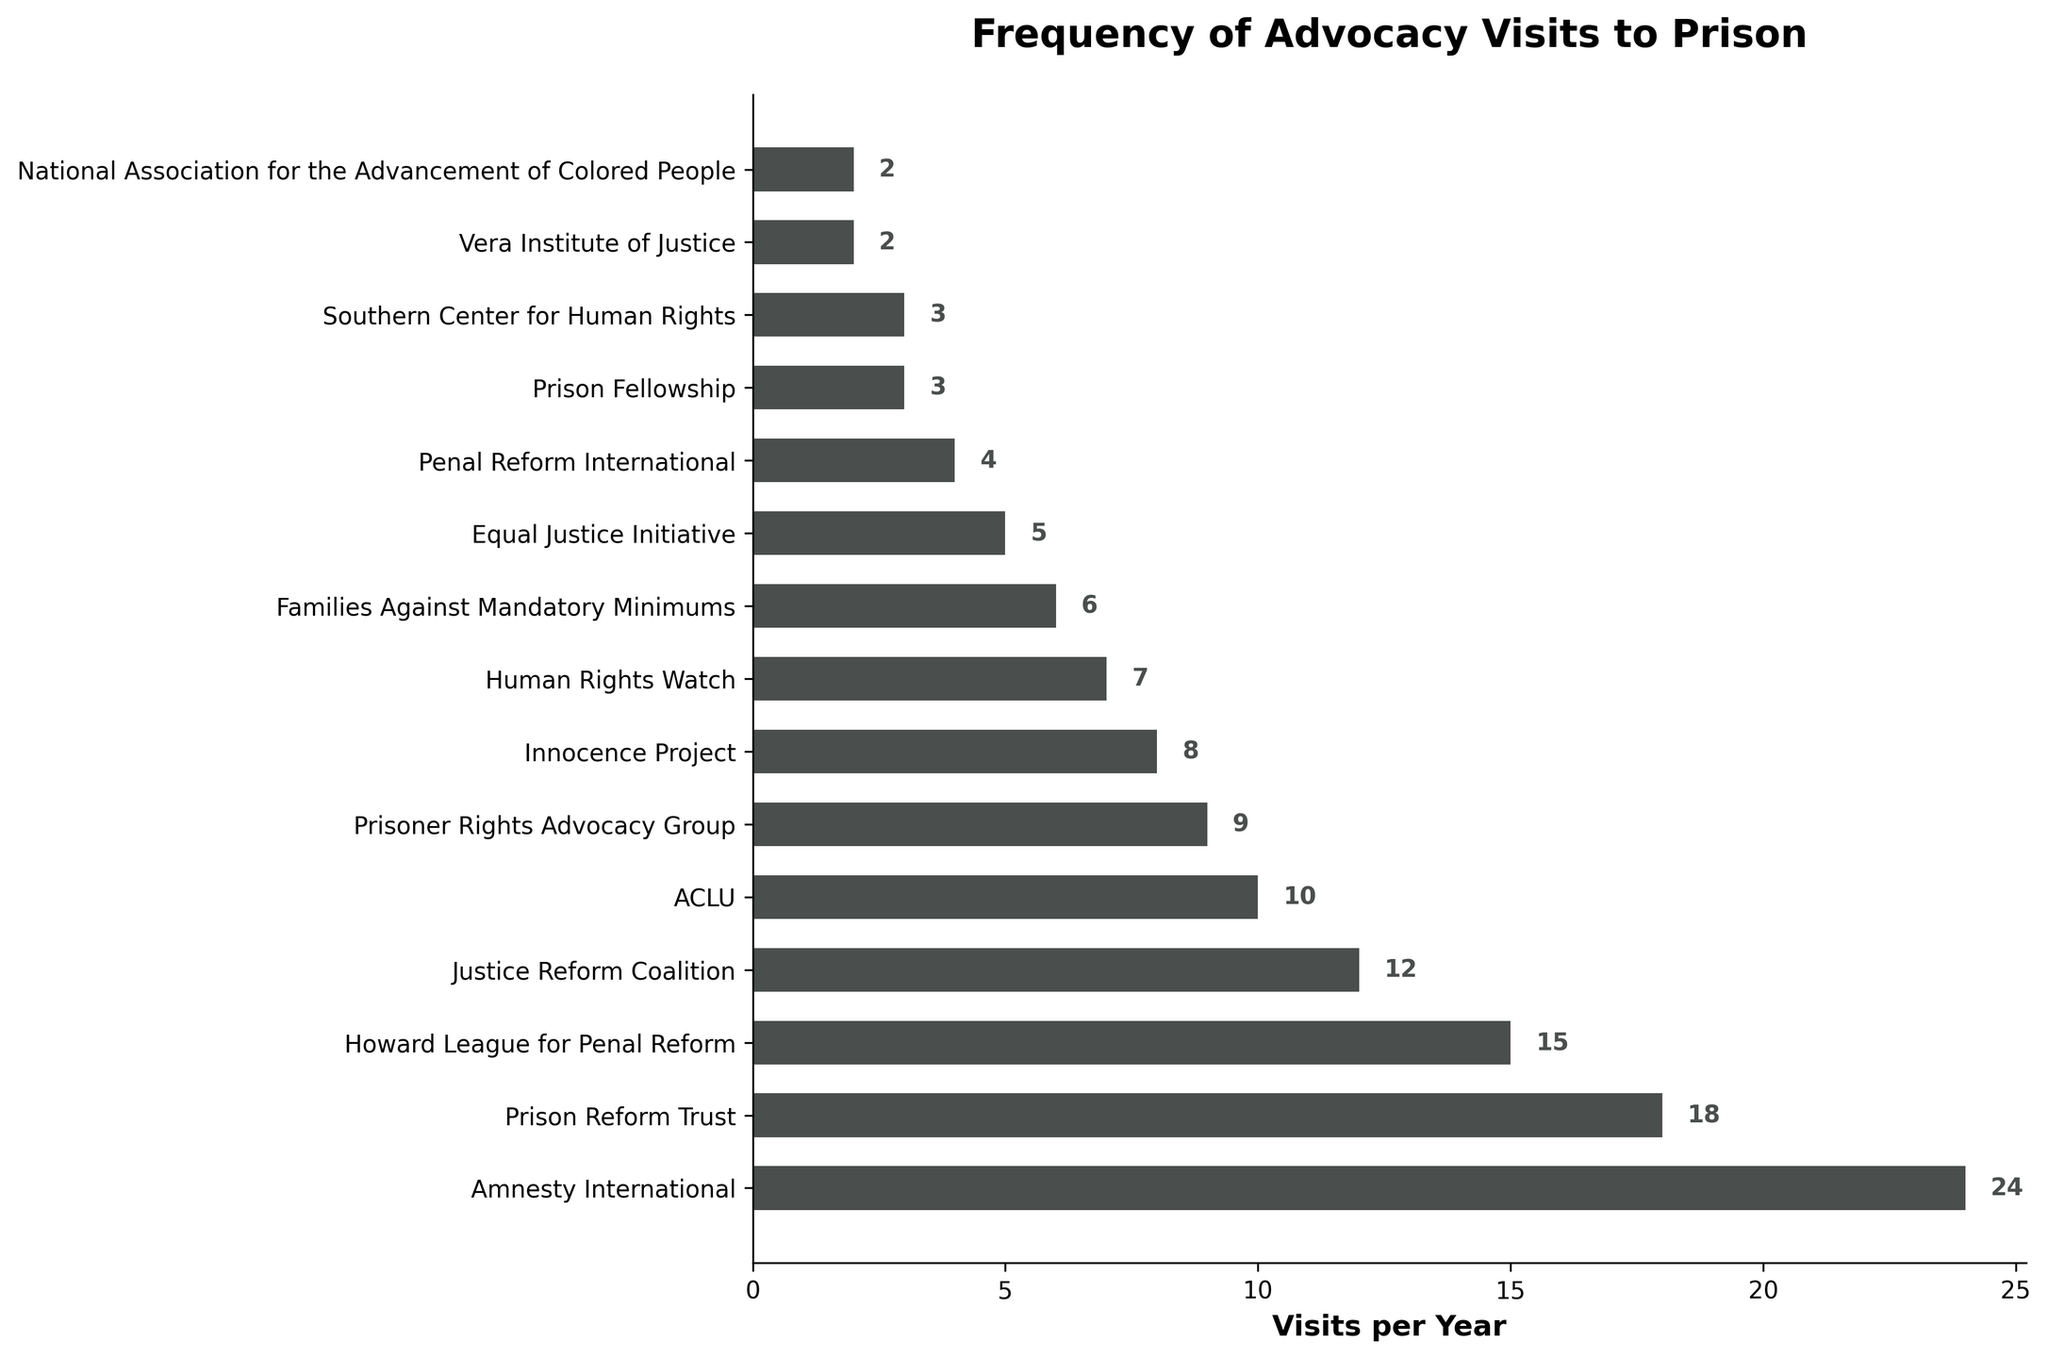Which organization has the highest number of advocacy visits per year? The figure shows the frequency of advocacy visits, and the organization with the longest bar is Amnesty International, making it clear they have the highest number of visits.
Answer: Amnesty International What is the difference in the number of visits per year between Amnesty International and the ACLU? Amnesty International has 24 visits per year, and the ACLU has 10. The difference is 24 - 10 = 14.
Answer: 14 Which organizations have fewer than 10 visits per year? Observing the length of the bars corresponding to visits fewer than 10, the organizations are Prisoner Rights Advocacy Group, Innocence Project, Human Rights Watch, Families Against Mandatory Minimums, Equal Justice Initiative, Penal Reform International, Prison Fellowship, Southern Center for Human Rights, Vera Institute of Justice, and National Association for the Advancement of Colored People.
Answer: Prisoner Rights Advocacy Group, Innocence Project, Human Rights Watch, Families Against Mandatory Minimums, Equal Justice Initiative, Penal Reform International, Prison Fellowship, Southern Center for Human Rights, Vera Institute of Justice, National Association for the Advancement of Colored People How many organizations have more than 10 advocacy visits per year? By counting the bars that extend beyond the 10 visit mark, the organizations include Amnesty International, Prison Reform Trust, Howard League for Penal Reform, and Justice Reform Coalition.
Answer: 4 What is the average number of advocacy visits per year across all organizations? The sum of all visits is 24 + 18 + 15 + 12 + 10 + 9 + 8 + 7 + 6 + 5 + 4 + 3 + 3 + 2 + 2 = 128. There are 15 organizations, so the average is 128 / 15 ≈ 8.53.
Answer: 8.53 Which organization has exactly 5 advocacy visits per year? The bar corresponding to Equal Justice Initiative shows exactly 5 visits per year.
Answer: Equal Justice Initiative Compare the combined number of visits by Amnesty International and Prison Reform Trust to that of the combined visits by Howard League for Penal Reform and ACLU. Which group has more visits? Amnesty International and Prison Reform Trust have a combined total of 24 + 18 = 42 visits, whereas Howard League for Penal Reform and ACLU have 15 + 10 = 25 visits. 42 is greater than 25.
Answer: Amnesty International and Prison Reform Trust What is the median number of visits per year? Listing the visits in ascending order: 2, 2, 3, 3, 4, 5, 6, 7, 8, 9, 10, 12, 15, 18, 24. The median is the middle value of this ordered list, which is 7.
Answer: 7 What is the combined number of visits for the bottom five organizations in terms of visits per year? The bottom five organizations are Vera Institute of Justice (2), National Association for the Advancement of Colored People (2), Prison Fellowship (3), Southern Center for Human Rights (3), and Penal Reform International (4). Their combined visits are 2 + 2 + 3 + 3 + 4 = 14.
Answer: 14 Which organization has the second highest number of advocacy visits per year? The second longest bar after Amnesty International belongs to Prison Reform Trust, indicating they have the second highest number of visits.
Answer: Prison Reform Trust 